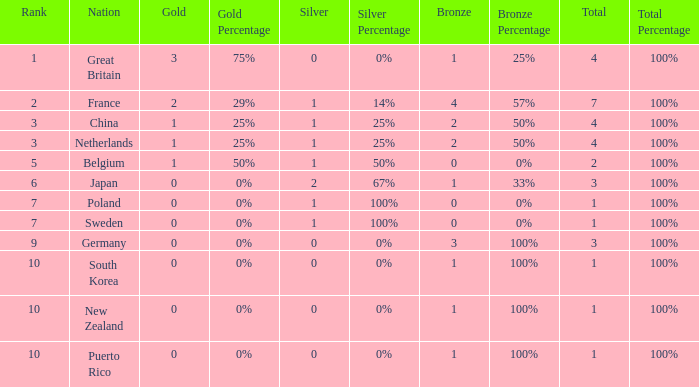What is the smallest number of gold where the total is less than 3 and the silver count is 2? None. 